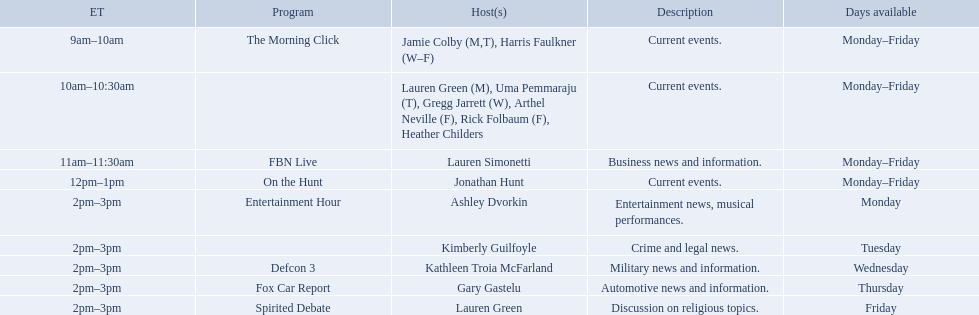Who are all of the hosts? Jamie Colby (M,T), Harris Faulkner (W–F), Lauren Green (M), Uma Pemmaraju (T), Gregg Jarrett (W), Arthel Neville (F), Rick Folbaum (F), Heather Childers, Lauren Simonetti, Jonathan Hunt, Ashley Dvorkin, Kimberly Guilfoyle, Kathleen Troia McFarland, Gary Gastelu, Lauren Green. Which hosts have shows on fridays? Jamie Colby (M,T), Harris Faulkner (W–F), Lauren Green (M), Uma Pemmaraju (T), Gregg Jarrett (W), Arthel Neville (F), Rick Folbaum (F), Heather Childers, Lauren Simonetti, Jonathan Hunt, Lauren Green. Of those, which host's show airs at 2pm? Lauren Green. 